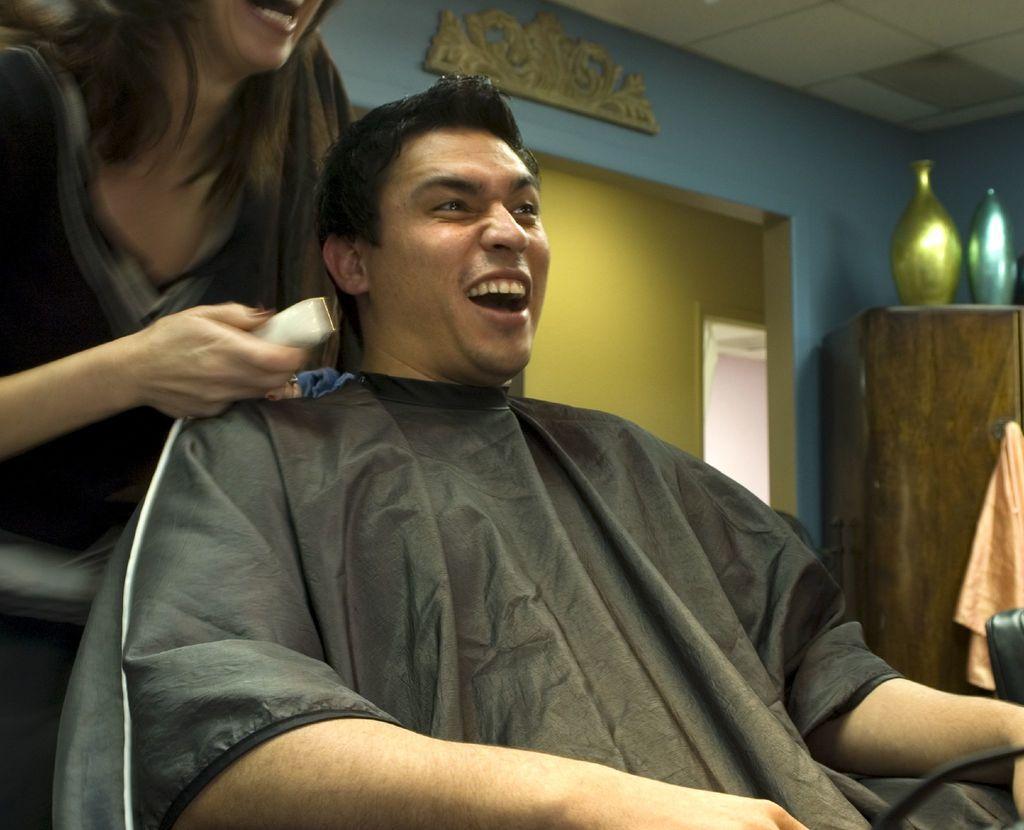In one or two sentences, can you explain what this image depicts? In this image, we can see two people are smiling. Here a woman is holding an object and man is sitting. Background we can see wall. Right side of the image, we can see wooden cupboard, cloth, decorative objects. Top of the image, there is a ceiling. 